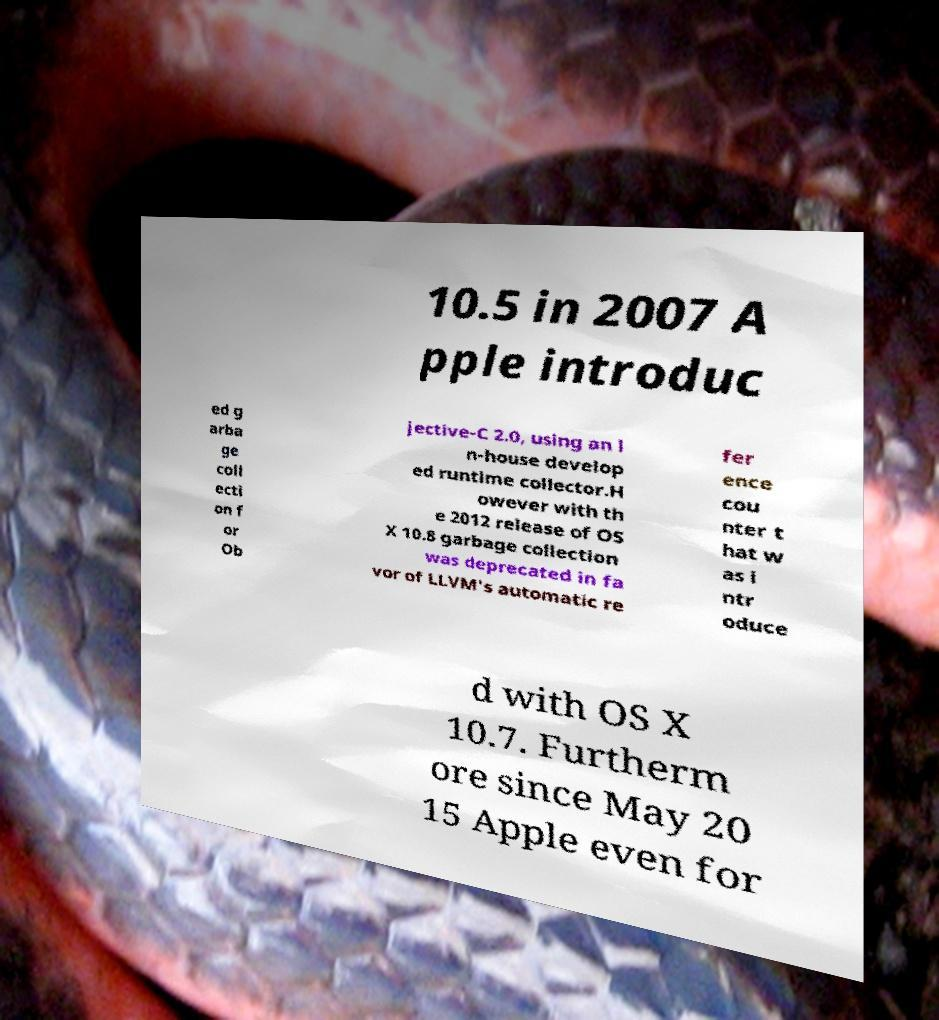What messages or text are displayed in this image? I need them in a readable, typed format. 10.5 in 2007 A pple introduc ed g arba ge coll ecti on f or Ob jective-C 2.0, using an i n-house develop ed runtime collector.H owever with th e 2012 release of OS X 10.8 garbage collection was deprecated in fa vor of LLVM's automatic re fer ence cou nter t hat w as i ntr oduce d with OS X 10.7. Furtherm ore since May 20 15 Apple even for 